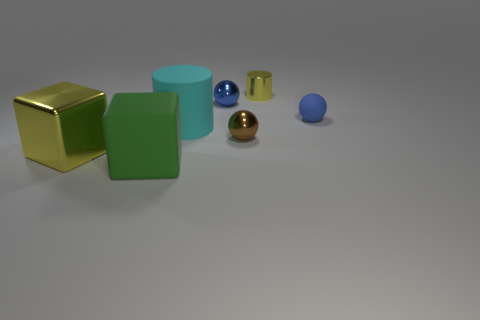What shape is the thing that is on the left side of the brown object and right of the cyan matte cylinder?
Provide a short and direct response. Sphere. The metallic block that is in front of the small metallic object in front of the cylinder that is in front of the small matte thing is what color?
Your answer should be very brief. Yellow. Are there fewer cyan things that are behind the blue rubber object than green things?
Provide a short and direct response. Yes. Does the blue thing that is to the right of the brown ball have the same shape as the large thing that is behind the large yellow metallic cube?
Ensure brevity in your answer.  No. What number of things are either things left of the tiny blue matte object or tiny brown matte objects?
Your response must be concise. 6. What is the material of the other sphere that is the same color as the rubber ball?
Give a very brief answer. Metal. Are there any large things that are on the right side of the small blue object right of the metallic ball that is in front of the rubber ball?
Keep it short and to the point. No. Are there fewer green rubber blocks that are left of the big green matte cube than blue metal objects that are in front of the small rubber ball?
Offer a very short reply. No. There is a block that is the same material as the tiny brown object; what color is it?
Ensure brevity in your answer.  Yellow. There is a cylinder that is on the left side of the small blue ball that is behind the blue rubber sphere; what is its color?
Your answer should be very brief. Cyan. 